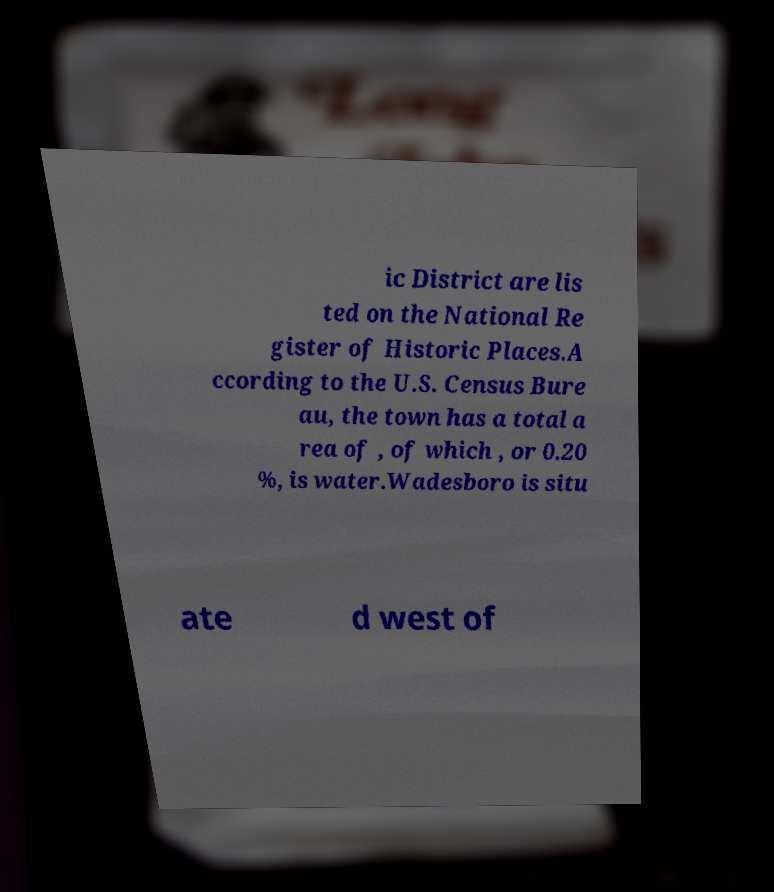For documentation purposes, I need the text within this image transcribed. Could you provide that? ic District are lis ted on the National Re gister of Historic Places.A ccording to the U.S. Census Bure au, the town has a total a rea of , of which , or 0.20 %, is water.Wadesboro is situ ate d west of 